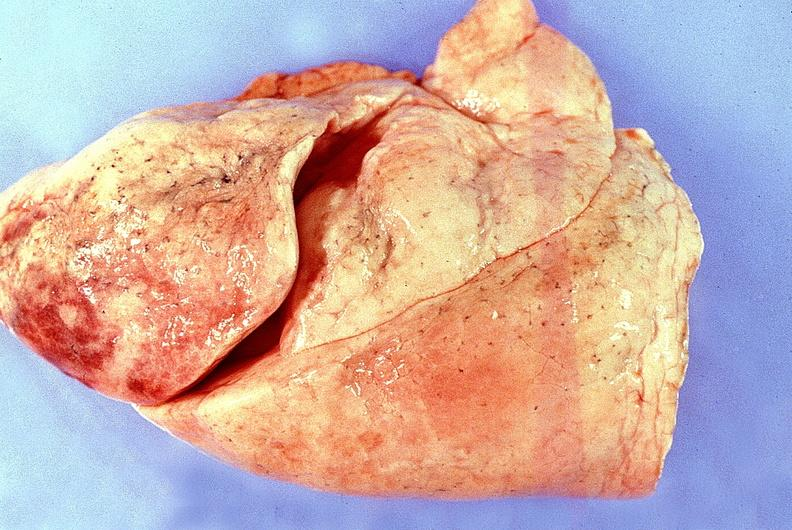does this image show normal lung?
Answer the question using a single word or phrase. Yes 